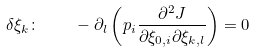Convert formula to latex. <formula><loc_0><loc_0><loc_500><loc_500>\delta \xi _ { k } \colon \quad - \partial _ { l } \left ( p _ { i } \frac { \partial ^ { 2 } J } { \partial \xi _ { 0 , i } \partial \xi _ { k , l } } \right ) = 0</formula> 